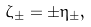<formula> <loc_0><loc_0><loc_500><loc_500>\zeta _ { \pm } = \pm \eta _ { \pm } ,</formula> 